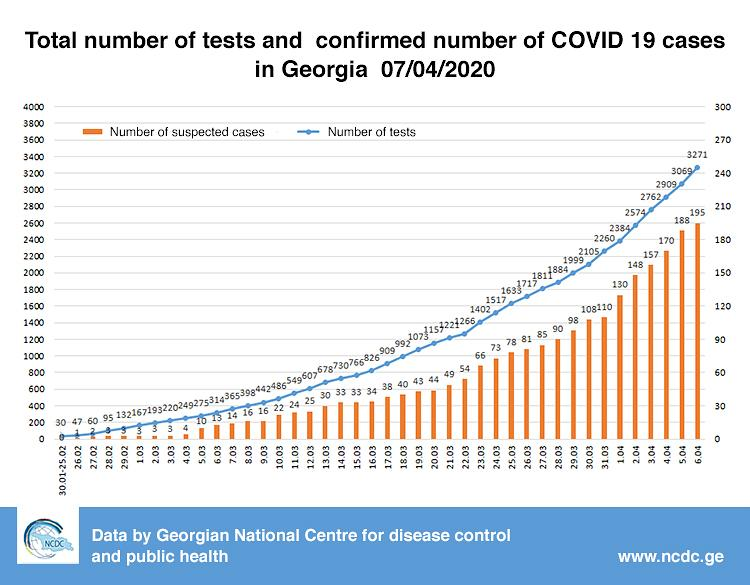Specify some key components in this picture. As of April 4, 2020, the number of COVID-19 tests performed in Georgia was 2,909. As of March 10, 2020, there were 22 reported suspected cases of COVID-19 in Georgia. As of March 22nd, 2020, there have been 54 suspected cases of COVID-19 reported in Georgia. As of April 5, 2020, a total of 3069 COVID-19 tests had been performed in the state of Georgia. As of March 16, 2020, there have been 34 suspected cases of COVID-19 reported in Georgia. 